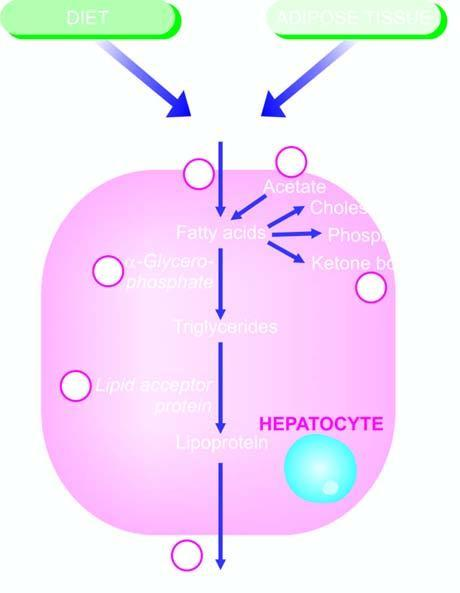can equence of events in the pathogenesis of reversible and irreversible cell injury number steps produce fatty liver by different etiologic agents?
Answer the question using a single word or phrase. No 